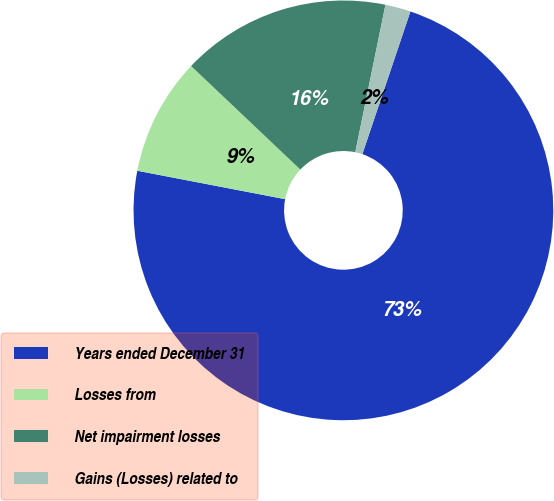Convert chart. <chart><loc_0><loc_0><loc_500><loc_500><pie_chart><fcel>Years ended December 31<fcel>Losses from<fcel>Net impairment losses<fcel>Gains (Losses) related to<nl><fcel>72.85%<fcel>9.05%<fcel>16.14%<fcel>1.96%<nl></chart> 